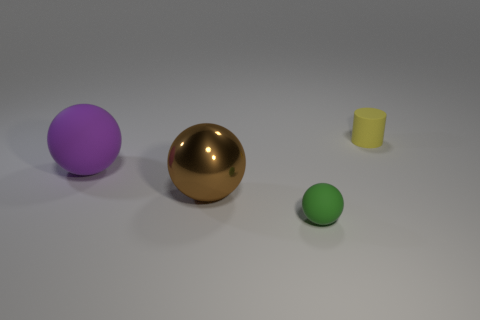What shape is the green thing that is the same material as the purple thing? sphere 